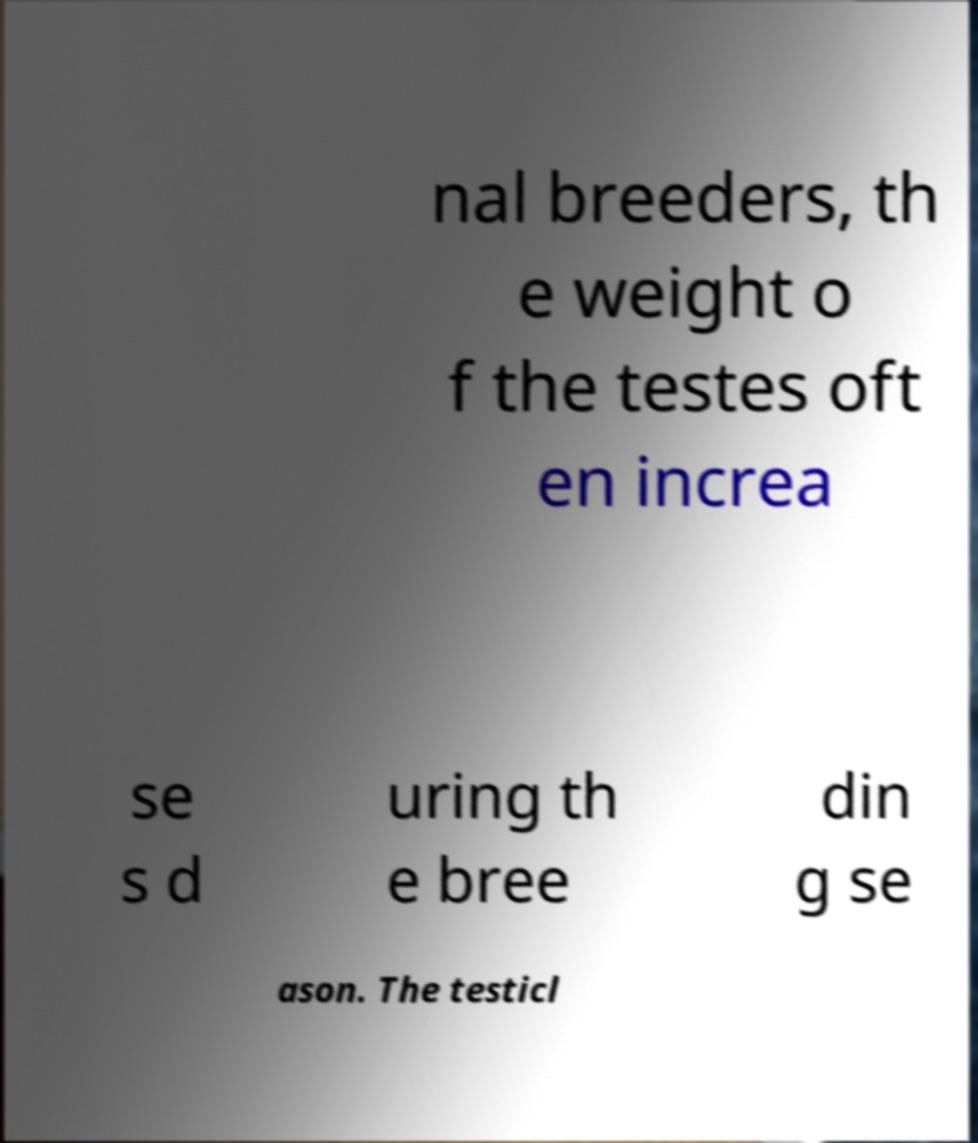I need the written content from this picture converted into text. Can you do that? nal breeders, th e weight o f the testes oft en increa se s d uring th e bree din g se ason. The testicl 